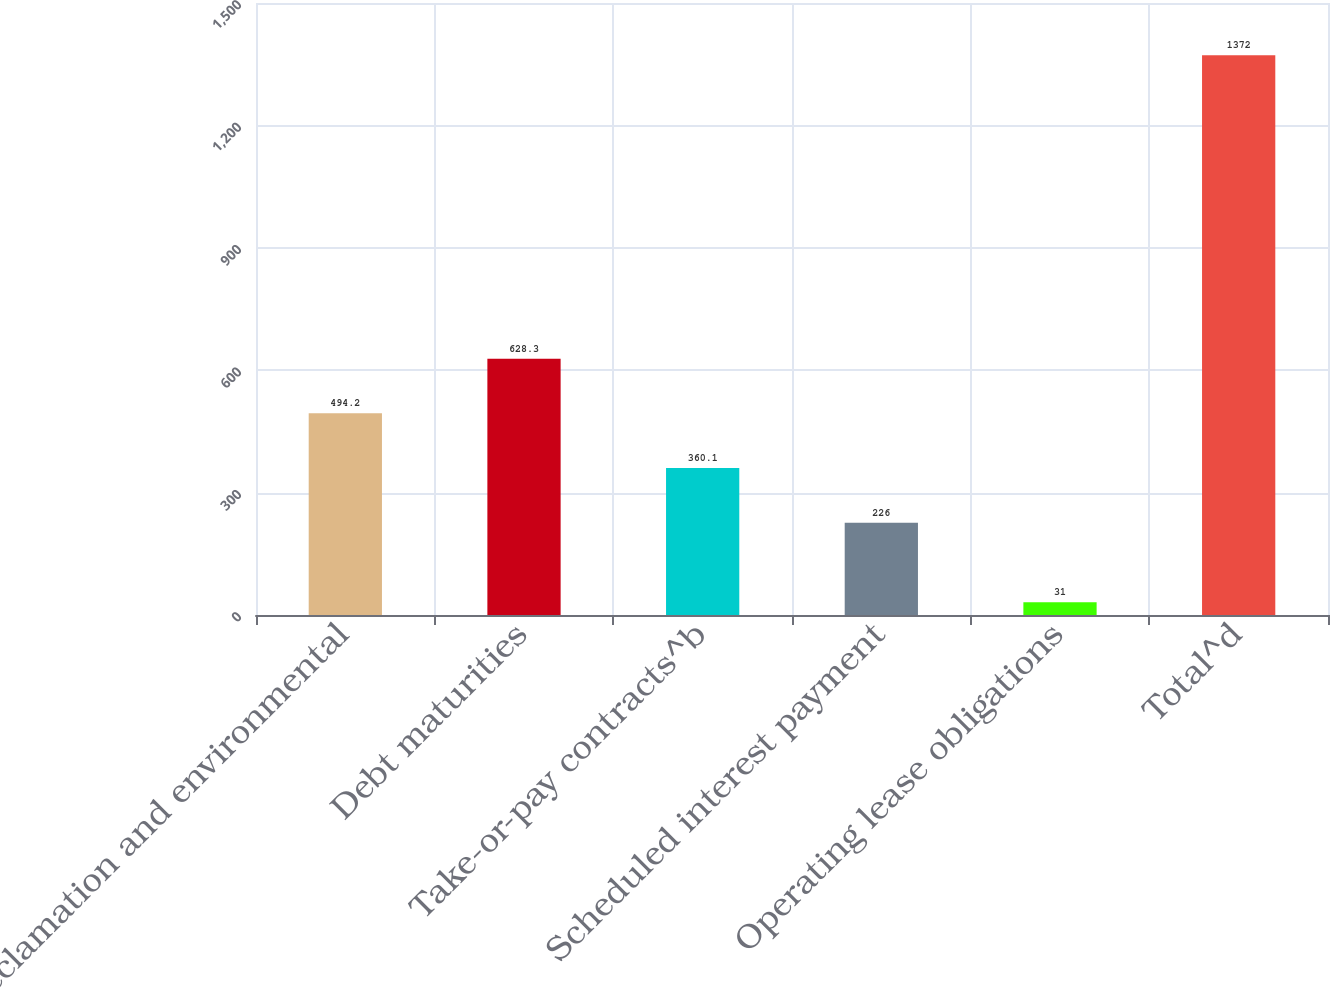Convert chart. <chart><loc_0><loc_0><loc_500><loc_500><bar_chart><fcel>Reclamation and environmental<fcel>Debt maturities<fcel>Take-or-pay contracts^b<fcel>Scheduled interest payment<fcel>Operating lease obligations<fcel>Total^d<nl><fcel>494.2<fcel>628.3<fcel>360.1<fcel>226<fcel>31<fcel>1372<nl></chart> 